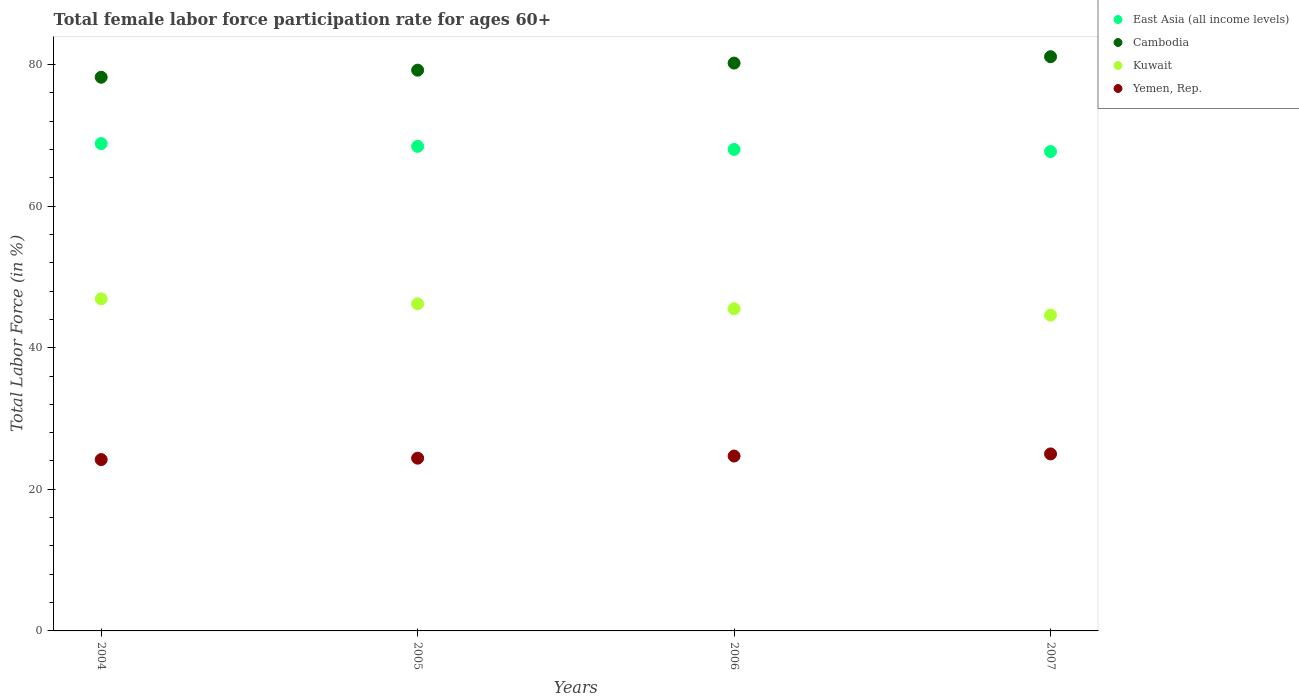Is the number of dotlines equal to the number of legend labels?
Keep it short and to the point. Yes. What is the female labor force participation rate in East Asia (all income levels) in 2004?
Provide a short and direct response. 68.83. Across all years, what is the maximum female labor force participation rate in Cambodia?
Offer a very short reply. 81.1. Across all years, what is the minimum female labor force participation rate in Kuwait?
Your response must be concise. 44.6. What is the total female labor force participation rate in Cambodia in the graph?
Ensure brevity in your answer.  318.7. What is the difference between the female labor force participation rate in Kuwait in 2004 and that in 2007?
Your answer should be very brief. 2.3. What is the difference between the female labor force participation rate in Cambodia in 2004 and the female labor force participation rate in Yemen, Rep. in 2007?
Make the answer very short. 53.2. What is the average female labor force participation rate in Kuwait per year?
Offer a terse response. 45.8. In the year 2004, what is the difference between the female labor force participation rate in Kuwait and female labor force participation rate in East Asia (all income levels)?
Provide a succinct answer. -21.93. In how many years, is the female labor force participation rate in East Asia (all income levels) greater than 36 %?
Offer a very short reply. 4. What is the ratio of the female labor force participation rate in Yemen, Rep. in 2004 to that in 2007?
Ensure brevity in your answer.  0.97. Is the female labor force participation rate in Yemen, Rep. in 2005 less than that in 2006?
Make the answer very short. Yes. What is the difference between the highest and the second highest female labor force participation rate in Cambodia?
Provide a succinct answer. 0.9. What is the difference between the highest and the lowest female labor force participation rate in Kuwait?
Make the answer very short. 2.3. Is it the case that in every year, the sum of the female labor force participation rate in Kuwait and female labor force participation rate in East Asia (all income levels)  is greater than the sum of female labor force participation rate in Yemen, Rep. and female labor force participation rate in Cambodia?
Your response must be concise. No. Does the female labor force participation rate in Cambodia monotonically increase over the years?
Your answer should be compact. Yes. How many years are there in the graph?
Give a very brief answer. 4. What is the difference between two consecutive major ticks on the Y-axis?
Your answer should be very brief. 20. Does the graph contain grids?
Make the answer very short. No. What is the title of the graph?
Provide a short and direct response. Total female labor force participation rate for ages 60+. What is the label or title of the Y-axis?
Keep it short and to the point. Total Labor Force (in %). What is the Total Labor Force (in %) in East Asia (all income levels) in 2004?
Your response must be concise. 68.83. What is the Total Labor Force (in %) in Cambodia in 2004?
Offer a terse response. 78.2. What is the Total Labor Force (in %) of Kuwait in 2004?
Your answer should be very brief. 46.9. What is the Total Labor Force (in %) of Yemen, Rep. in 2004?
Offer a very short reply. 24.2. What is the Total Labor Force (in %) in East Asia (all income levels) in 2005?
Ensure brevity in your answer.  68.44. What is the Total Labor Force (in %) in Cambodia in 2005?
Keep it short and to the point. 79.2. What is the Total Labor Force (in %) of Kuwait in 2005?
Provide a succinct answer. 46.2. What is the Total Labor Force (in %) in Yemen, Rep. in 2005?
Provide a succinct answer. 24.4. What is the Total Labor Force (in %) of East Asia (all income levels) in 2006?
Provide a short and direct response. 68.01. What is the Total Labor Force (in %) of Cambodia in 2006?
Offer a very short reply. 80.2. What is the Total Labor Force (in %) of Kuwait in 2006?
Offer a very short reply. 45.5. What is the Total Labor Force (in %) in Yemen, Rep. in 2006?
Ensure brevity in your answer.  24.7. What is the Total Labor Force (in %) in East Asia (all income levels) in 2007?
Provide a short and direct response. 67.71. What is the Total Labor Force (in %) of Cambodia in 2007?
Ensure brevity in your answer.  81.1. What is the Total Labor Force (in %) in Kuwait in 2007?
Provide a succinct answer. 44.6. What is the Total Labor Force (in %) in Yemen, Rep. in 2007?
Ensure brevity in your answer.  25. Across all years, what is the maximum Total Labor Force (in %) of East Asia (all income levels)?
Give a very brief answer. 68.83. Across all years, what is the maximum Total Labor Force (in %) of Cambodia?
Keep it short and to the point. 81.1. Across all years, what is the maximum Total Labor Force (in %) of Kuwait?
Make the answer very short. 46.9. Across all years, what is the minimum Total Labor Force (in %) of East Asia (all income levels)?
Your answer should be very brief. 67.71. Across all years, what is the minimum Total Labor Force (in %) in Cambodia?
Provide a succinct answer. 78.2. Across all years, what is the minimum Total Labor Force (in %) in Kuwait?
Your answer should be compact. 44.6. Across all years, what is the minimum Total Labor Force (in %) in Yemen, Rep.?
Provide a short and direct response. 24.2. What is the total Total Labor Force (in %) in East Asia (all income levels) in the graph?
Make the answer very short. 272.99. What is the total Total Labor Force (in %) of Cambodia in the graph?
Keep it short and to the point. 318.7. What is the total Total Labor Force (in %) of Kuwait in the graph?
Keep it short and to the point. 183.2. What is the total Total Labor Force (in %) in Yemen, Rep. in the graph?
Offer a terse response. 98.3. What is the difference between the Total Labor Force (in %) in East Asia (all income levels) in 2004 and that in 2005?
Make the answer very short. 0.39. What is the difference between the Total Labor Force (in %) in Kuwait in 2004 and that in 2005?
Keep it short and to the point. 0.7. What is the difference between the Total Labor Force (in %) of Yemen, Rep. in 2004 and that in 2005?
Offer a very short reply. -0.2. What is the difference between the Total Labor Force (in %) of East Asia (all income levels) in 2004 and that in 2006?
Provide a short and direct response. 0.82. What is the difference between the Total Labor Force (in %) in Kuwait in 2004 and that in 2006?
Your answer should be very brief. 1.4. What is the difference between the Total Labor Force (in %) in East Asia (all income levels) in 2004 and that in 2007?
Your answer should be compact. 1.12. What is the difference between the Total Labor Force (in %) in Kuwait in 2004 and that in 2007?
Your response must be concise. 2.3. What is the difference between the Total Labor Force (in %) in East Asia (all income levels) in 2005 and that in 2006?
Your answer should be very brief. 0.43. What is the difference between the Total Labor Force (in %) of Cambodia in 2005 and that in 2006?
Ensure brevity in your answer.  -1. What is the difference between the Total Labor Force (in %) in Kuwait in 2005 and that in 2006?
Provide a succinct answer. 0.7. What is the difference between the Total Labor Force (in %) in East Asia (all income levels) in 2005 and that in 2007?
Provide a short and direct response. 0.73. What is the difference between the Total Labor Force (in %) in East Asia (all income levels) in 2006 and that in 2007?
Provide a short and direct response. 0.29. What is the difference between the Total Labor Force (in %) of Cambodia in 2006 and that in 2007?
Make the answer very short. -0.9. What is the difference between the Total Labor Force (in %) of Yemen, Rep. in 2006 and that in 2007?
Your answer should be compact. -0.3. What is the difference between the Total Labor Force (in %) of East Asia (all income levels) in 2004 and the Total Labor Force (in %) of Cambodia in 2005?
Ensure brevity in your answer.  -10.37. What is the difference between the Total Labor Force (in %) of East Asia (all income levels) in 2004 and the Total Labor Force (in %) of Kuwait in 2005?
Your response must be concise. 22.63. What is the difference between the Total Labor Force (in %) of East Asia (all income levels) in 2004 and the Total Labor Force (in %) of Yemen, Rep. in 2005?
Your answer should be compact. 44.43. What is the difference between the Total Labor Force (in %) in Cambodia in 2004 and the Total Labor Force (in %) in Kuwait in 2005?
Make the answer very short. 32. What is the difference between the Total Labor Force (in %) in Cambodia in 2004 and the Total Labor Force (in %) in Yemen, Rep. in 2005?
Your answer should be compact. 53.8. What is the difference between the Total Labor Force (in %) in East Asia (all income levels) in 2004 and the Total Labor Force (in %) in Cambodia in 2006?
Make the answer very short. -11.37. What is the difference between the Total Labor Force (in %) of East Asia (all income levels) in 2004 and the Total Labor Force (in %) of Kuwait in 2006?
Provide a succinct answer. 23.33. What is the difference between the Total Labor Force (in %) of East Asia (all income levels) in 2004 and the Total Labor Force (in %) of Yemen, Rep. in 2006?
Your answer should be compact. 44.13. What is the difference between the Total Labor Force (in %) in Cambodia in 2004 and the Total Labor Force (in %) in Kuwait in 2006?
Your answer should be very brief. 32.7. What is the difference between the Total Labor Force (in %) in Cambodia in 2004 and the Total Labor Force (in %) in Yemen, Rep. in 2006?
Give a very brief answer. 53.5. What is the difference between the Total Labor Force (in %) of East Asia (all income levels) in 2004 and the Total Labor Force (in %) of Cambodia in 2007?
Give a very brief answer. -12.27. What is the difference between the Total Labor Force (in %) in East Asia (all income levels) in 2004 and the Total Labor Force (in %) in Kuwait in 2007?
Ensure brevity in your answer.  24.23. What is the difference between the Total Labor Force (in %) of East Asia (all income levels) in 2004 and the Total Labor Force (in %) of Yemen, Rep. in 2007?
Keep it short and to the point. 43.83. What is the difference between the Total Labor Force (in %) in Cambodia in 2004 and the Total Labor Force (in %) in Kuwait in 2007?
Your answer should be compact. 33.6. What is the difference between the Total Labor Force (in %) in Cambodia in 2004 and the Total Labor Force (in %) in Yemen, Rep. in 2007?
Your answer should be compact. 53.2. What is the difference between the Total Labor Force (in %) of Kuwait in 2004 and the Total Labor Force (in %) of Yemen, Rep. in 2007?
Provide a short and direct response. 21.9. What is the difference between the Total Labor Force (in %) in East Asia (all income levels) in 2005 and the Total Labor Force (in %) in Cambodia in 2006?
Provide a short and direct response. -11.76. What is the difference between the Total Labor Force (in %) in East Asia (all income levels) in 2005 and the Total Labor Force (in %) in Kuwait in 2006?
Keep it short and to the point. 22.94. What is the difference between the Total Labor Force (in %) of East Asia (all income levels) in 2005 and the Total Labor Force (in %) of Yemen, Rep. in 2006?
Give a very brief answer. 43.74. What is the difference between the Total Labor Force (in %) in Cambodia in 2005 and the Total Labor Force (in %) in Kuwait in 2006?
Offer a very short reply. 33.7. What is the difference between the Total Labor Force (in %) of Cambodia in 2005 and the Total Labor Force (in %) of Yemen, Rep. in 2006?
Your answer should be very brief. 54.5. What is the difference between the Total Labor Force (in %) of East Asia (all income levels) in 2005 and the Total Labor Force (in %) of Cambodia in 2007?
Provide a short and direct response. -12.66. What is the difference between the Total Labor Force (in %) of East Asia (all income levels) in 2005 and the Total Labor Force (in %) of Kuwait in 2007?
Keep it short and to the point. 23.84. What is the difference between the Total Labor Force (in %) in East Asia (all income levels) in 2005 and the Total Labor Force (in %) in Yemen, Rep. in 2007?
Offer a very short reply. 43.44. What is the difference between the Total Labor Force (in %) of Cambodia in 2005 and the Total Labor Force (in %) of Kuwait in 2007?
Your answer should be very brief. 34.6. What is the difference between the Total Labor Force (in %) in Cambodia in 2005 and the Total Labor Force (in %) in Yemen, Rep. in 2007?
Offer a terse response. 54.2. What is the difference between the Total Labor Force (in %) of Kuwait in 2005 and the Total Labor Force (in %) of Yemen, Rep. in 2007?
Ensure brevity in your answer.  21.2. What is the difference between the Total Labor Force (in %) in East Asia (all income levels) in 2006 and the Total Labor Force (in %) in Cambodia in 2007?
Your response must be concise. -13.09. What is the difference between the Total Labor Force (in %) of East Asia (all income levels) in 2006 and the Total Labor Force (in %) of Kuwait in 2007?
Make the answer very short. 23.41. What is the difference between the Total Labor Force (in %) of East Asia (all income levels) in 2006 and the Total Labor Force (in %) of Yemen, Rep. in 2007?
Make the answer very short. 43.01. What is the difference between the Total Labor Force (in %) of Cambodia in 2006 and the Total Labor Force (in %) of Kuwait in 2007?
Ensure brevity in your answer.  35.6. What is the difference between the Total Labor Force (in %) of Cambodia in 2006 and the Total Labor Force (in %) of Yemen, Rep. in 2007?
Your response must be concise. 55.2. What is the difference between the Total Labor Force (in %) of Kuwait in 2006 and the Total Labor Force (in %) of Yemen, Rep. in 2007?
Offer a terse response. 20.5. What is the average Total Labor Force (in %) in East Asia (all income levels) per year?
Give a very brief answer. 68.25. What is the average Total Labor Force (in %) of Cambodia per year?
Keep it short and to the point. 79.67. What is the average Total Labor Force (in %) in Kuwait per year?
Provide a succinct answer. 45.8. What is the average Total Labor Force (in %) of Yemen, Rep. per year?
Give a very brief answer. 24.57. In the year 2004, what is the difference between the Total Labor Force (in %) of East Asia (all income levels) and Total Labor Force (in %) of Cambodia?
Make the answer very short. -9.37. In the year 2004, what is the difference between the Total Labor Force (in %) in East Asia (all income levels) and Total Labor Force (in %) in Kuwait?
Offer a terse response. 21.93. In the year 2004, what is the difference between the Total Labor Force (in %) of East Asia (all income levels) and Total Labor Force (in %) of Yemen, Rep.?
Ensure brevity in your answer.  44.63. In the year 2004, what is the difference between the Total Labor Force (in %) in Cambodia and Total Labor Force (in %) in Kuwait?
Offer a very short reply. 31.3. In the year 2004, what is the difference between the Total Labor Force (in %) of Cambodia and Total Labor Force (in %) of Yemen, Rep.?
Your response must be concise. 54. In the year 2004, what is the difference between the Total Labor Force (in %) of Kuwait and Total Labor Force (in %) of Yemen, Rep.?
Keep it short and to the point. 22.7. In the year 2005, what is the difference between the Total Labor Force (in %) in East Asia (all income levels) and Total Labor Force (in %) in Cambodia?
Your answer should be compact. -10.76. In the year 2005, what is the difference between the Total Labor Force (in %) in East Asia (all income levels) and Total Labor Force (in %) in Kuwait?
Provide a short and direct response. 22.24. In the year 2005, what is the difference between the Total Labor Force (in %) in East Asia (all income levels) and Total Labor Force (in %) in Yemen, Rep.?
Provide a short and direct response. 44.04. In the year 2005, what is the difference between the Total Labor Force (in %) in Cambodia and Total Labor Force (in %) in Kuwait?
Provide a short and direct response. 33. In the year 2005, what is the difference between the Total Labor Force (in %) in Cambodia and Total Labor Force (in %) in Yemen, Rep.?
Provide a short and direct response. 54.8. In the year 2005, what is the difference between the Total Labor Force (in %) of Kuwait and Total Labor Force (in %) of Yemen, Rep.?
Your answer should be very brief. 21.8. In the year 2006, what is the difference between the Total Labor Force (in %) of East Asia (all income levels) and Total Labor Force (in %) of Cambodia?
Offer a terse response. -12.19. In the year 2006, what is the difference between the Total Labor Force (in %) in East Asia (all income levels) and Total Labor Force (in %) in Kuwait?
Your answer should be compact. 22.51. In the year 2006, what is the difference between the Total Labor Force (in %) in East Asia (all income levels) and Total Labor Force (in %) in Yemen, Rep.?
Make the answer very short. 43.31. In the year 2006, what is the difference between the Total Labor Force (in %) in Cambodia and Total Labor Force (in %) in Kuwait?
Offer a very short reply. 34.7. In the year 2006, what is the difference between the Total Labor Force (in %) in Cambodia and Total Labor Force (in %) in Yemen, Rep.?
Keep it short and to the point. 55.5. In the year 2006, what is the difference between the Total Labor Force (in %) in Kuwait and Total Labor Force (in %) in Yemen, Rep.?
Offer a terse response. 20.8. In the year 2007, what is the difference between the Total Labor Force (in %) in East Asia (all income levels) and Total Labor Force (in %) in Cambodia?
Ensure brevity in your answer.  -13.39. In the year 2007, what is the difference between the Total Labor Force (in %) in East Asia (all income levels) and Total Labor Force (in %) in Kuwait?
Offer a very short reply. 23.11. In the year 2007, what is the difference between the Total Labor Force (in %) in East Asia (all income levels) and Total Labor Force (in %) in Yemen, Rep.?
Ensure brevity in your answer.  42.71. In the year 2007, what is the difference between the Total Labor Force (in %) of Cambodia and Total Labor Force (in %) of Kuwait?
Your answer should be compact. 36.5. In the year 2007, what is the difference between the Total Labor Force (in %) in Cambodia and Total Labor Force (in %) in Yemen, Rep.?
Give a very brief answer. 56.1. In the year 2007, what is the difference between the Total Labor Force (in %) in Kuwait and Total Labor Force (in %) in Yemen, Rep.?
Provide a short and direct response. 19.6. What is the ratio of the Total Labor Force (in %) in Cambodia in 2004 to that in 2005?
Make the answer very short. 0.99. What is the ratio of the Total Labor Force (in %) of Kuwait in 2004 to that in 2005?
Offer a very short reply. 1.02. What is the ratio of the Total Labor Force (in %) of East Asia (all income levels) in 2004 to that in 2006?
Make the answer very short. 1.01. What is the ratio of the Total Labor Force (in %) of Cambodia in 2004 to that in 2006?
Provide a succinct answer. 0.98. What is the ratio of the Total Labor Force (in %) in Kuwait in 2004 to that in 2006?
Offer a terse response. 1.03. What is the ratio of the Total Labor Force (in %) in Yemen, Rep. in 2004 to that in 2006?
Provide a succinct answer. 0.98. What is the ratio of the Total Labor Force (in %) of East Asia (all income levels) in 2004 to that in 2007?
Your answer should be very brief. 1.02. What is the ratio of the Total Labor Force (in %) in Cambodia in 2004 to that in 2007?
Your answer should be compact. 0.96. What is the ratio of the Total Labor Force (in %) in Kuwait in 2004 to that in 2007?
Your response must be concise. 1.05. What is the ratio of the Total Labor Force (in %) of Yemen, Rep. in 2004 to that in 2007?
Ensure brevity in your answer.  0.97. What is the ratio of the Total Labor Force (in %) in East Asia (all income levels) in 2005 to that in 2006?
Provide a short and direct response. 1.01. What is the ratio of the Total Labor Force (in %) of Cambodia in 2005 to that in 2006?
Keep it short and to the point. 0.99. What is the ratio of the Total Labor Force (in %) of Kuwait in 2005 to that in 2006?
Your response must be concise. 1.02. What is the ratio of the Total Labor Force (in %) of Yemen, Rep. in 2005 to that in 2006?
Your response must be concise. 0.99. What is the ratio of the Total Labor Force (in %) in East Asia (all income levels) in 2005 to that in 2007?
Your answer should be compact. 1.01. What is the ratio of the Total Labor Force (in %) of Cambodia in 2005 to that in 2007?
Make the answer very short. 0.98. What is the ratio of the Total Labor Force (in %) of Kuwait in 2005 to that in 2007?
Your response must be concise. 1.04. What is the ratio of the Total Labor Force (in %) of Yemen, Rep. in 2005 to that in 2007?
Provide a succinct answer. 0.98. What is the ratio of the Total Labor Force (in %) in East Asia (all income levels) in 2006 to that in 2007?
Offer a very short reply. 1. What is the ratio of the Total Labor Force (in %) in Cambodia in 2006 to that in 2007?
Your answer should be compact. 0.99. What is the ratio of the Total Labor Force (in %) of Kuwait in 2006 to that in 2007?
Your answer should be very brief. 1.02. What is the difference between the highest and the second highest Total Labor Force (in %) in East Asia (all income levels)?
Your answer should be very brief. 0.39. What is the difference between the highest and the second highest Total Labor Force (in %) in Cambodia?
Provide a succinct answer. 0.9. What is the difference between the highest and the second highest Total Labor Force (in %) of Kuwait?
Provide a succinct answer. 0.7. What is the difference between the highest and the lowest Total Labor Force (in %) in East Asia (all income levels)?
Your response must be concise. 1.12. What is the difference between the highest and the lowest Total Labor Force (in %) in Cambodia?
Provide a succinct answer. 2.9. What is the difference between the highest and the lowest Total Labor Force (in %) of Kuwait?
Your answer should be very brief. 2.3. 